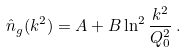<formula> <loc_0><loc_0><loc_500><loc_500>\hat { n } _ { g } ( k ^ { 2 } ) = A + B \ln ^ { 2 } \frac { k ^ { 2 } } { Q _ { 0 } ^ { 2 } } \, .</formula> 